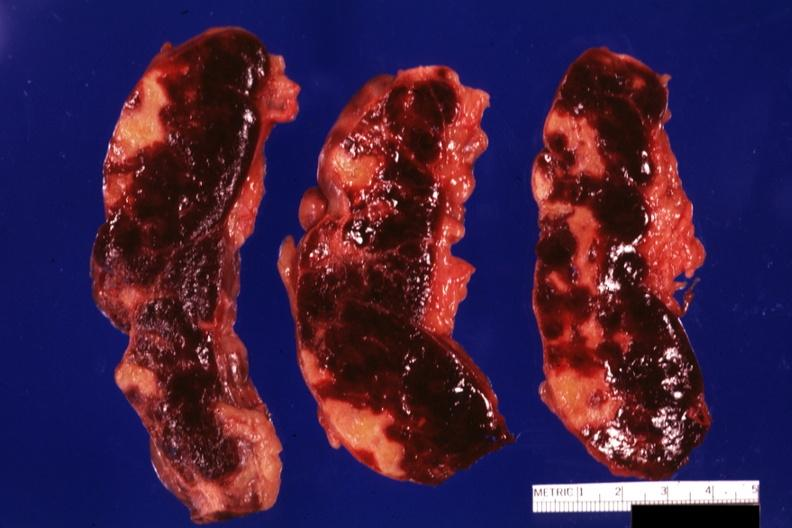what is present?
Answer the question using a single word or phrase. Spleen 